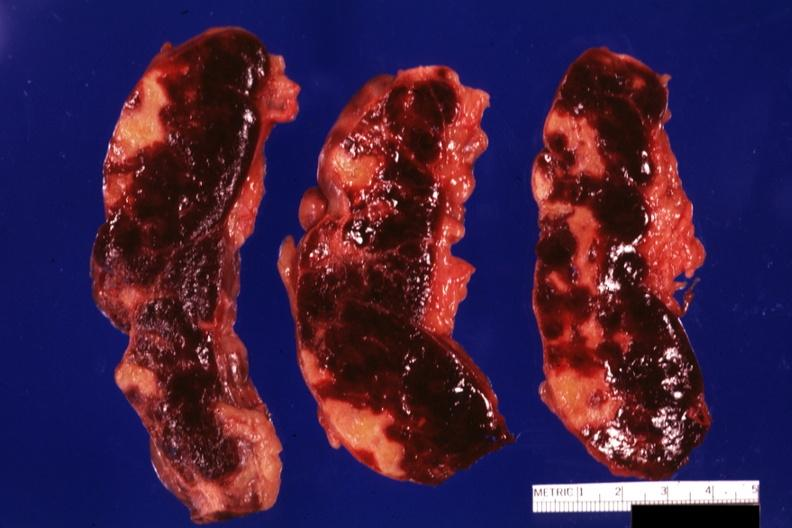what is present?
Answer the question using a single word or phrase. Spleen 